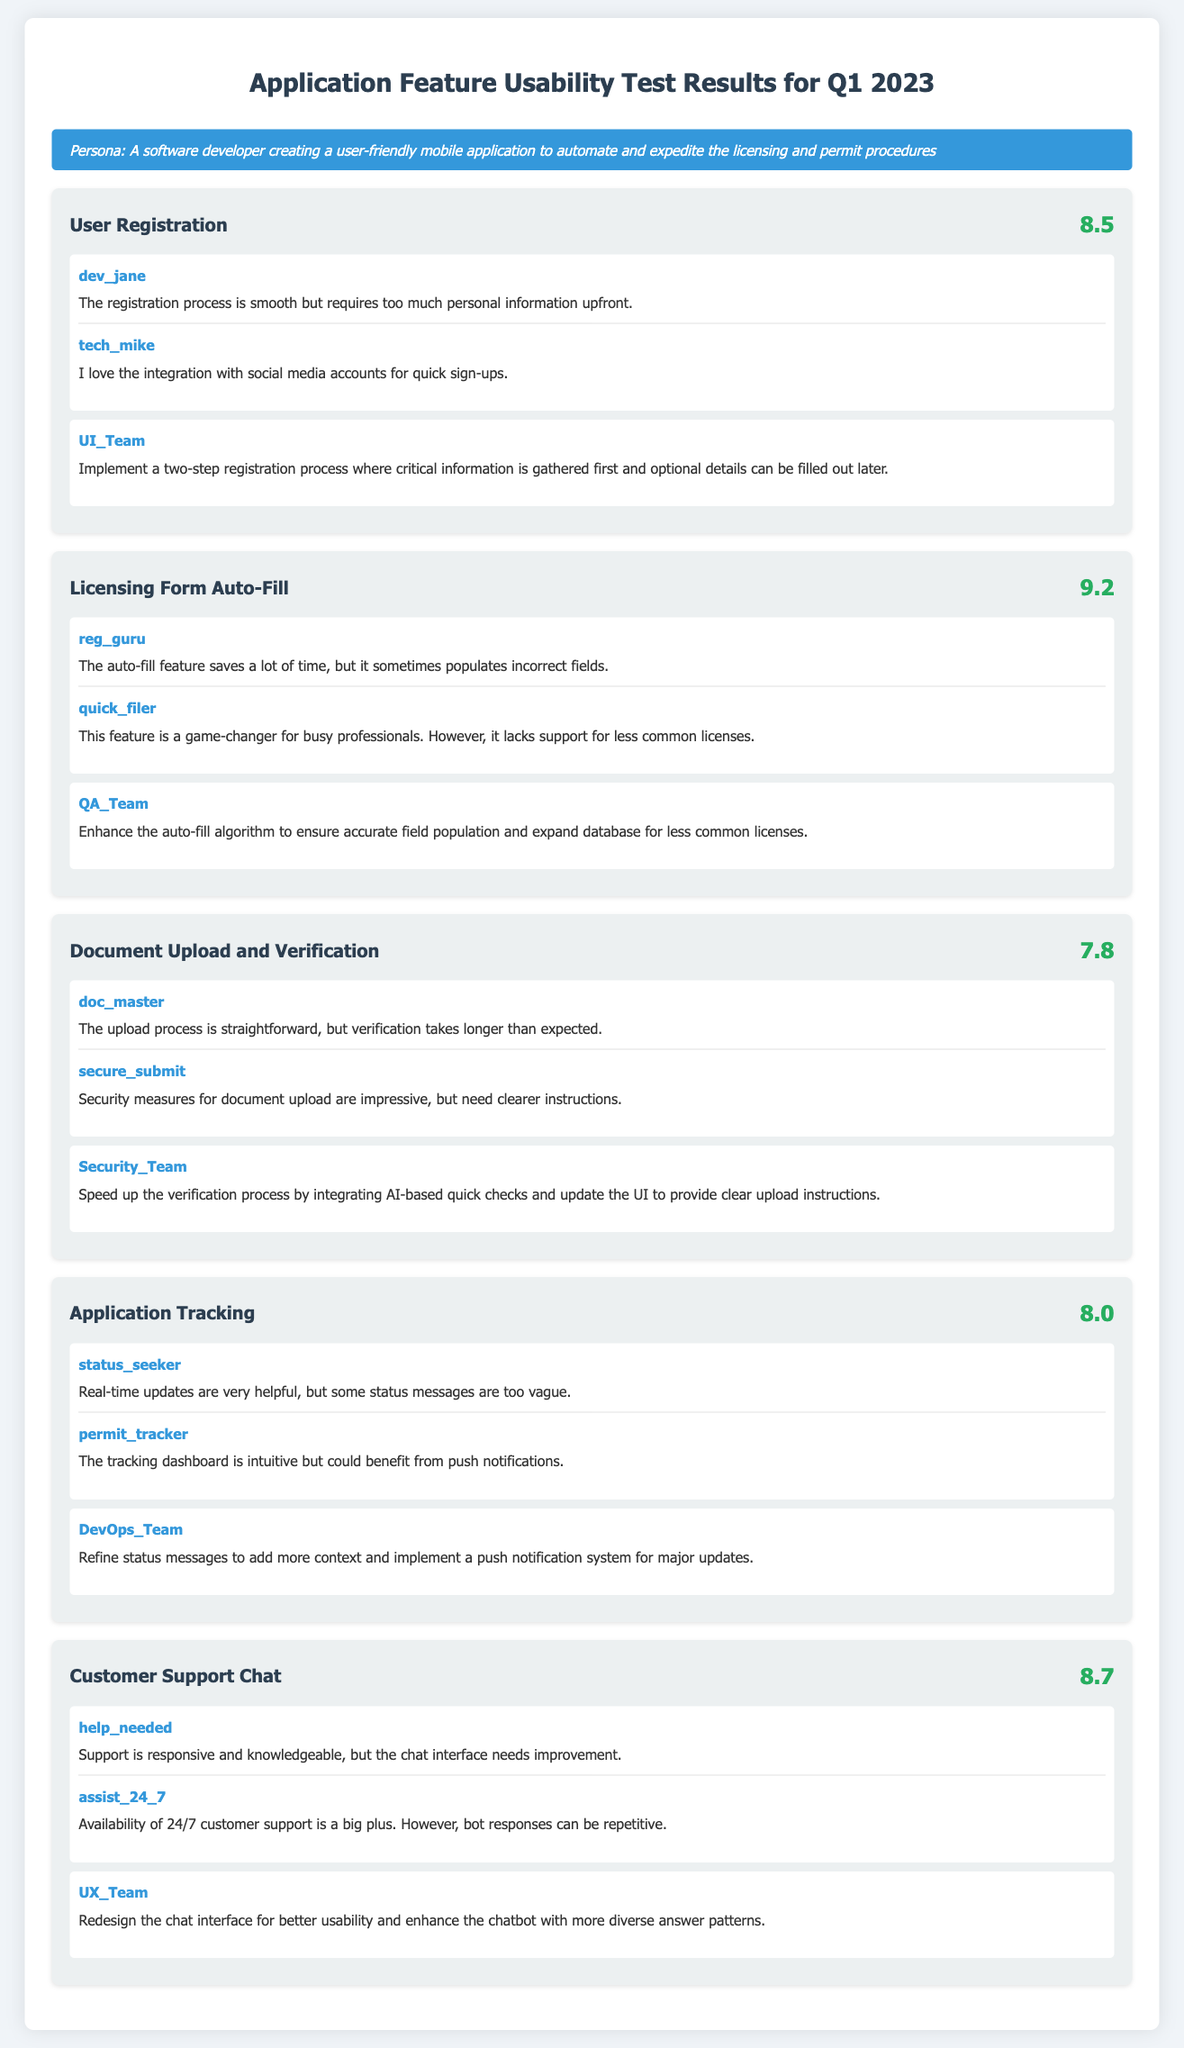What was the score for the Document Upload and Verification feature? The score for the Document Upload and Verification feature is indicated in the feature card, which shows a score of 7.8.
Answer: 7.8 Who provided feedback on the licensing form auto-fill feature? Feedback is provided by multiple users, specifically reg_guru and quick_filer for the licensing form auto-fill feature.
Answer: reg_guru, quick_filer What suggestion was made for improving the User Registration process? The suggestion made by UI_Team to improve the User Registration process is to implement a two-step registration process.
Answer: Two-step registration process What is a key benefit mentioned about the Customer Support Chat? The key benefit mentioned about the Customer Support Chat is the availability of 24/7 customer support.
Answer: 24/7 customer support What major suggestion relates to the Application Tracking feature? The suggestion made by the DevOps_Team for the Application Tracking feature is to refine status messages and implement a push notification system.
Answer: Refine status messages and implement push notifications What percentage of users rated the Licensing Form Auto-Fill feature above 9? The Licensing Form Auto-Fill feature received a score of 9.2, which indicates a high rating above 9.
Answer: 9.2 